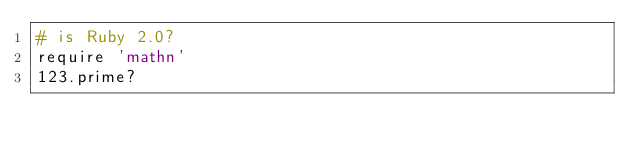Convert code to text. <code><loc_0><loc_0><loc_500><loc_500><_Ruby_># is Ruby 2.0?
require 'mathn'
123.prime?</code> 